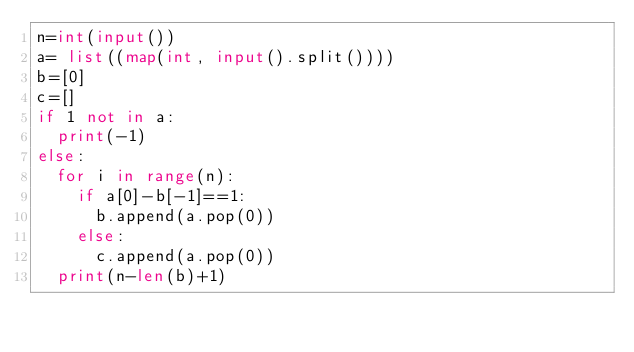<code> <loc_0><loc_0><loc_500><loc_500><_Python_>n=int(input())
a= list((map(int, input().split()))) 
b=[0]
c=[]
if 1 not in a:
  print(-1)
else:  
  for i in range(n):
    if a[0]-b[-1]==1:
      b.append(a.pop(0))
    else:
      c.append(a.pop(0))
  print(n-len(b)+1)</code> 